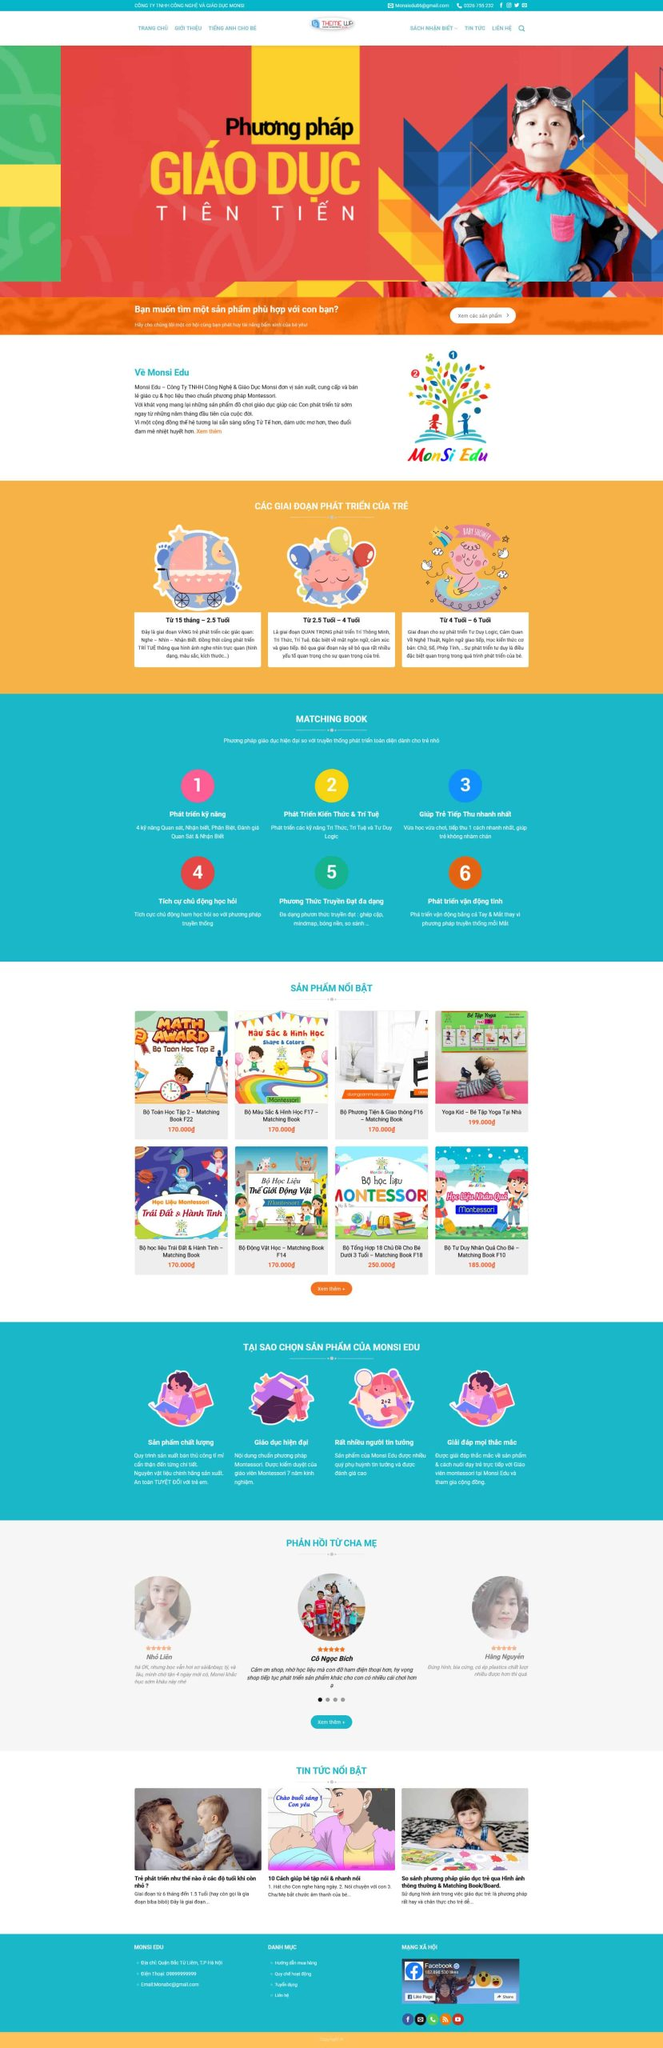Liệt kê 5 ngành nghề, lĩnh vực phù hợp với website này, phân cách các màu sắc bằng dấu phẩy. Chỉ trả về kết quả, phân cách bằng dấy phẩy
 Giáo dục, Đồ chơi trẻ em, Phát triển kỹ năng, Sách thiếu nhi, Đào tạo trực tuyến 